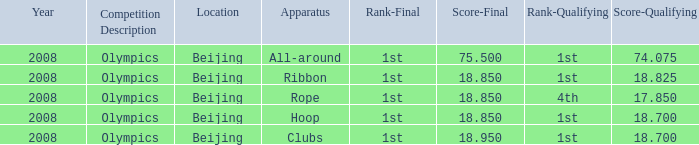What was her final score on the ribbon apparatus? 18.85. 